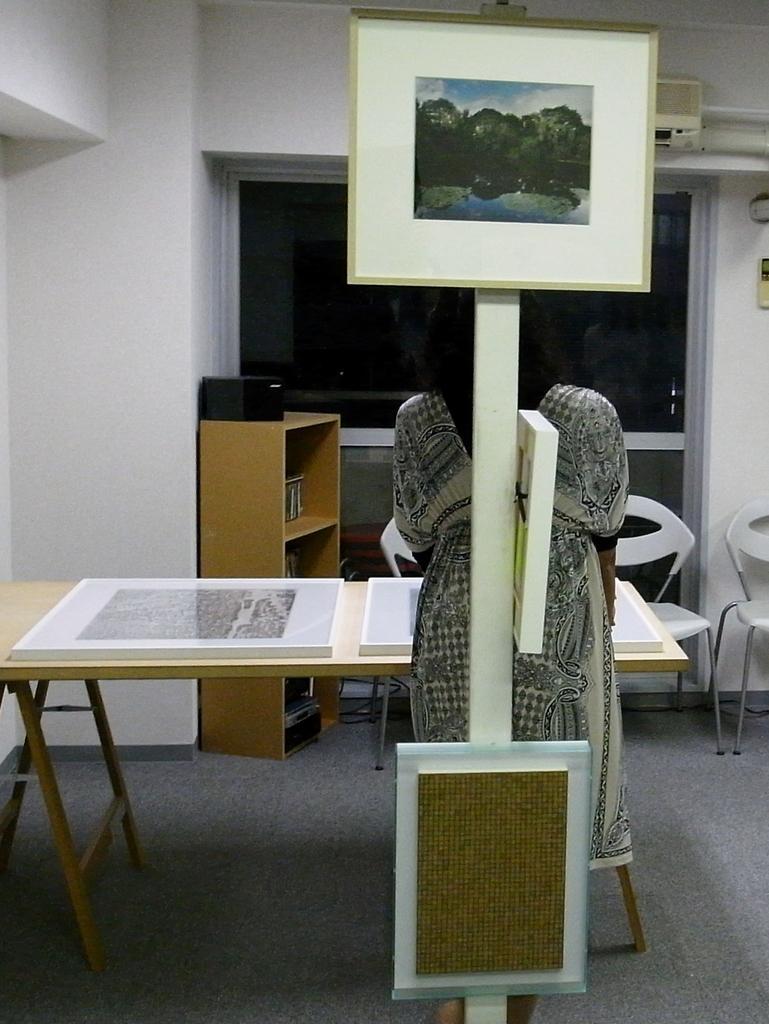Can you describe this image briefly? A lady is facing her back in the image. Behind her there is pole with a photograph mounted to it and beneath it a piece of box. There is a table in front of her with two objects on it. In the background there is a stand filled with objects and a black box on top of it. There are three white chairs in the background. An AC is mounted to the wall in the top right corner of the image. Two Glass doors are in the background. 